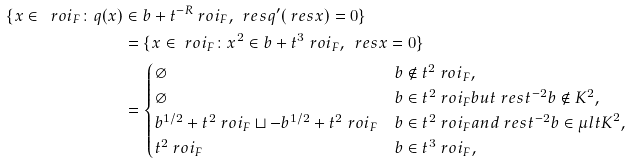Convert formula to latex. <formula><loc_0><loc_0><loc_500><loc_500>\{ x \in \ r o i _ { F } \colon q ( x ) & \in b + t ^ { - R } \ r o i _ { F } , \, \ r e s { q } ^ { \prime } ( \ r e s { x } ) = 0 \} \\ & = \{ x \in \ r o i _ { F } \colon x ^ { 2 } \in b + t ^ { 3 } \ r o i _ { F } , \, \ r e s { x } = 0 \} \\ & = \begin{cases} \varnothing & b \notin t ^ { 2 } \ r o i _ { F } , \\ \varnothing & b \in t ^ { 2 } \ r o i _ { F } b u t \ r e s { t ^ { - 2 } b } \notin K ^ { 2 } , \\ b ^ { 1 / 2 } + t ^ { 2 } \ r o i _ { F } \sqcup - b ^ { 1 / 2 } + t ^ { 2 } \ r o i _ { F } & b \in t ^ { 2 } \ r o i _ { F } a n d \ r e s { t ^ { - 2 } b } \in { \mu l t { K } } ^ { 2 } , \\ t ^ { 2 } \ r o i _ { F } & b \in t ^ { 3 } \ r o i _ { F } , \end{cases}</formula> 